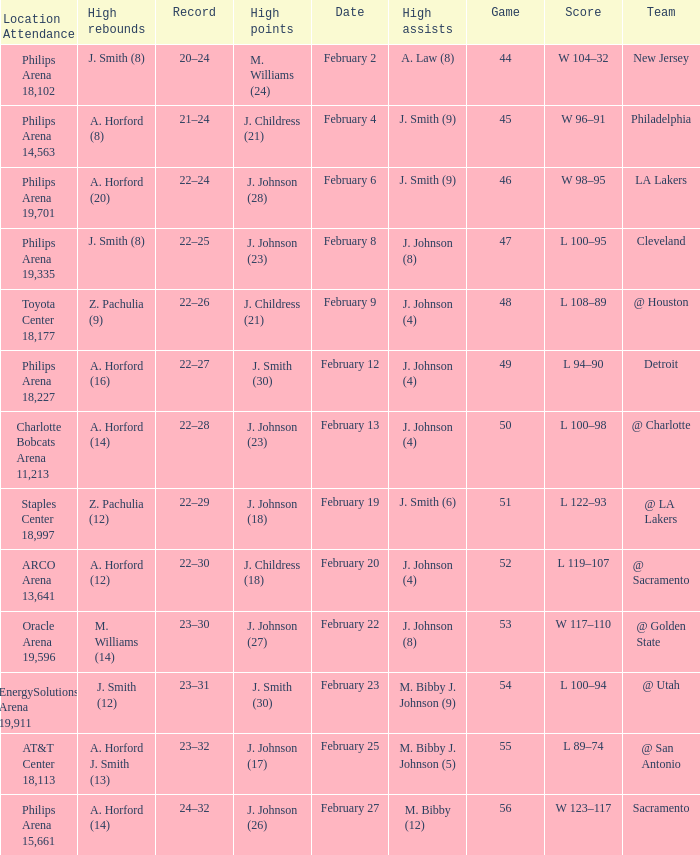Name the number of teams at the philips arena 19,335? 1.0. 